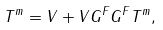Convert formula to latex. <formula><loc_0><loc_0><loc_500><loc_500>T ^ { m } = V + V G ^ { F } G ^ { F } T ^ { m } ,</formula> 